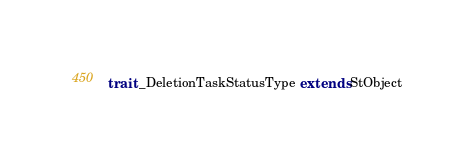Convert code to text. <code><loc_0><loc_0><loc_500><loc_500><_Scala_>
trait _DeletionTaskStatusType extends StObject
</code> 